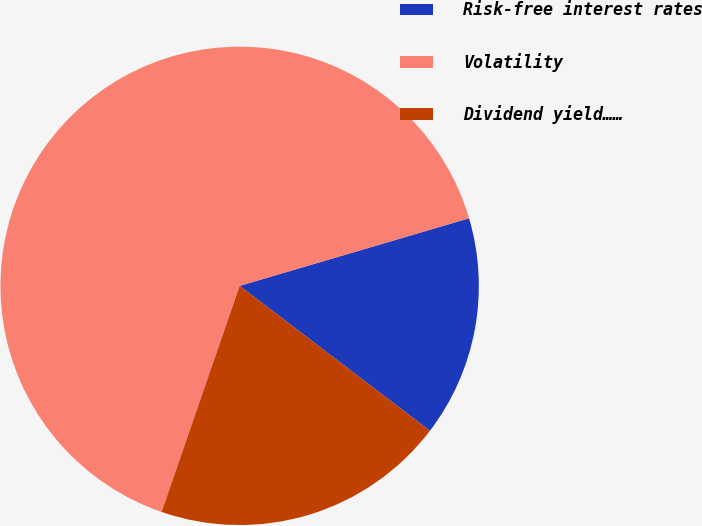<chart> <loc_0><loc_0><loc_500><loc_500><pie_chart><fcel>Risk-free interest rates<fcel>Volatility<fcel>Dividend yield……<nl><fcel>14.92%<fcel>65.15%<fcel>19.93%<nl></chart> 